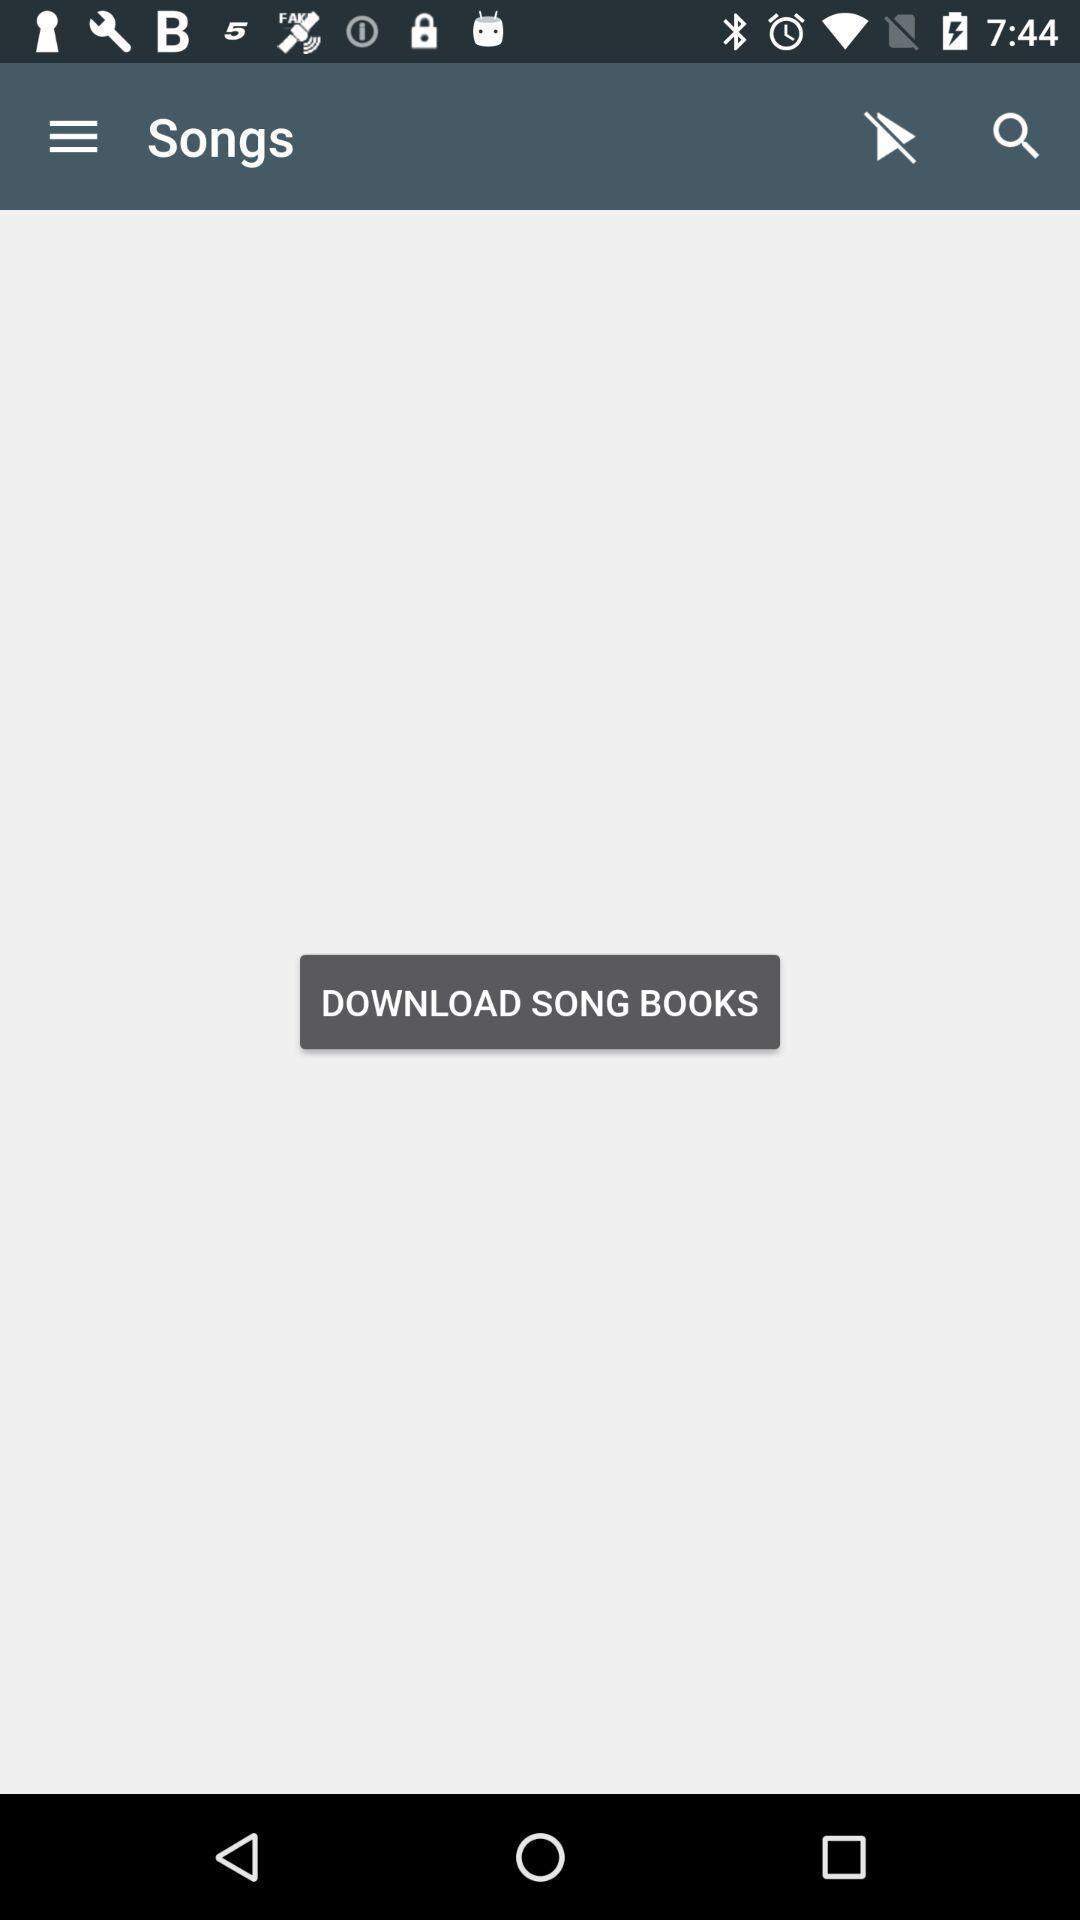Explain the elements present in this screenshot. Page showing songs available. 